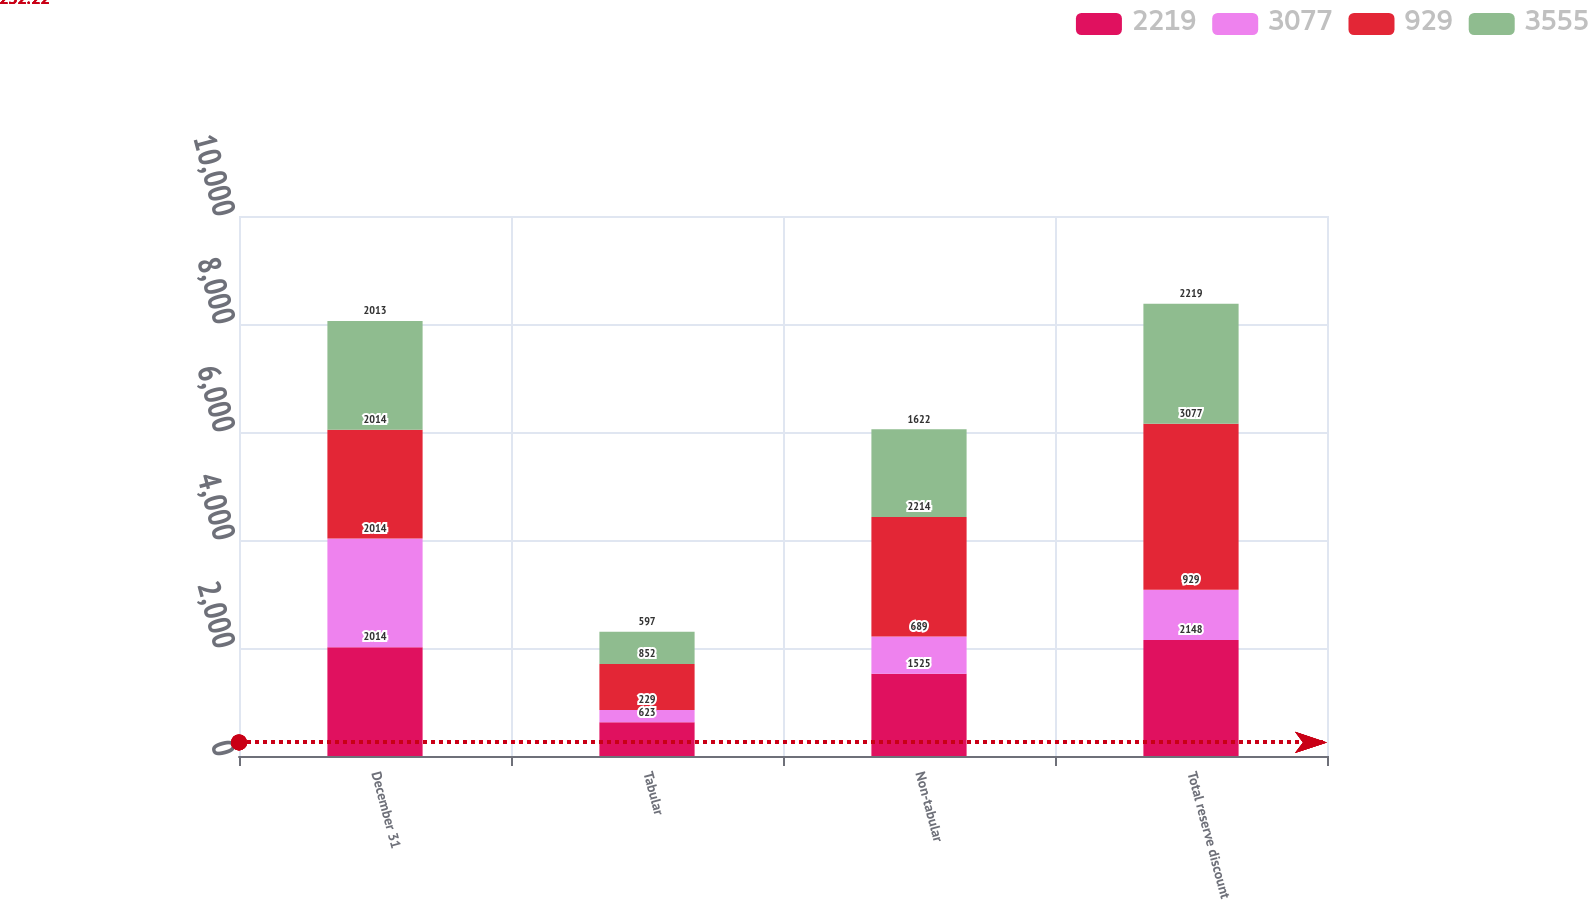Convert chart to OTSL. <chart><loc_0><loc_0><loc_500><loc_500><stacked_bar_chart><ecel><fcel>December 31<fcel>Tabular<fcel>Non-tabular<fcel>Total reserve discount<nl><fcel>2219<fcel>2014<fcel>623<fcel>1525<fcel>2148<nl><fcel>3077<fcel>2014<fcel>229<fcel>689<fcel>929<nl><fcel>929<fcel>2014<fcel>852<fcel>2214<fcel>3077<nl><fcel>3555<fcel>2013<fcel>597<fcel>1622<fcel>2219<nl></chart> 